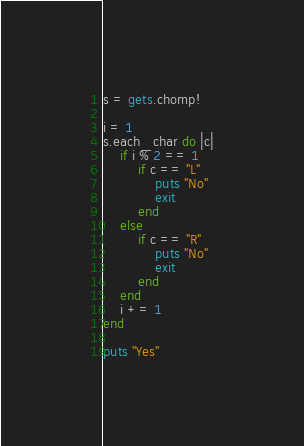<code> <loc_0><loc_0><loc_500><loc_500><_Ruby_>s = gets.chomp!

i = 1
s.each_char do |c|
    if i % 2 == 1
        if c == "L"
            puts "No"
            exit
        end
    else
        if c == "R"
            puts "No"
            exit
        end
    end
    i += 1
end

puts "Yes"</code> 